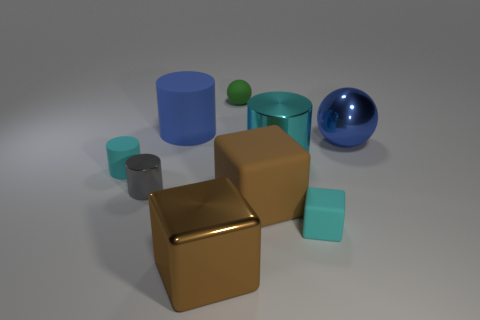Subtract all big brown cubes. How many cubes are left? 1 Subtract 1 spheres. How many spheres are left? 1 Add 1 large brown metal blocks. How many objects exist? 10 Subtract all cyan cubes. How many cubes are left? 2 Subtract 1 cyan cubes. How many objects are left? 8 Subtract all cubes. How many objects are left? 6 Subtract all brown blocks. Subtract all purple cylinders. How many blocks are left? 1 Subtract all blue blocks. How many brown cylinders are left? 0 Subtract all gray cylinders. Subtract all rubber spheres. How many objects are left? 7 Add 1 small cyan cylinders. How many small cyan cylinders are left? 2 